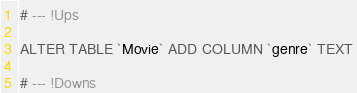<code> <loc_0><loc_0><loc_500><loc_500><_SQL_># --- !Ups

ALTER TABLE `Movie` ADD COLUMN `genre` TEXT

# --- !Downs

</code> 